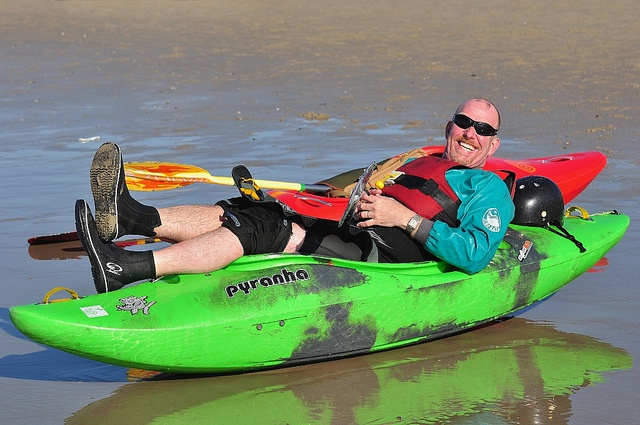Describe the objects in this image and their specific colors. I can see boat in darkgray, lime, gray, and green tones, people in darkgray, black, lightpink, teal, and gray tones, and surfboard in darkgray, red, salmon, and brown tones in this image. 